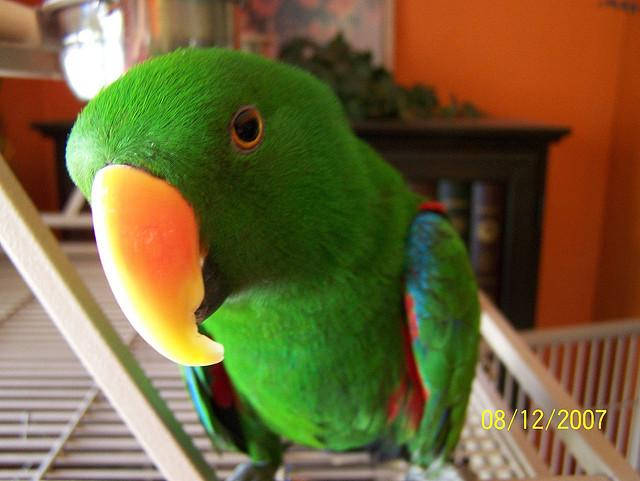Which bird can grind their own calcium supplements?

Choices:
A) peacock
B) dove
C) parrot
D) crow parrot 